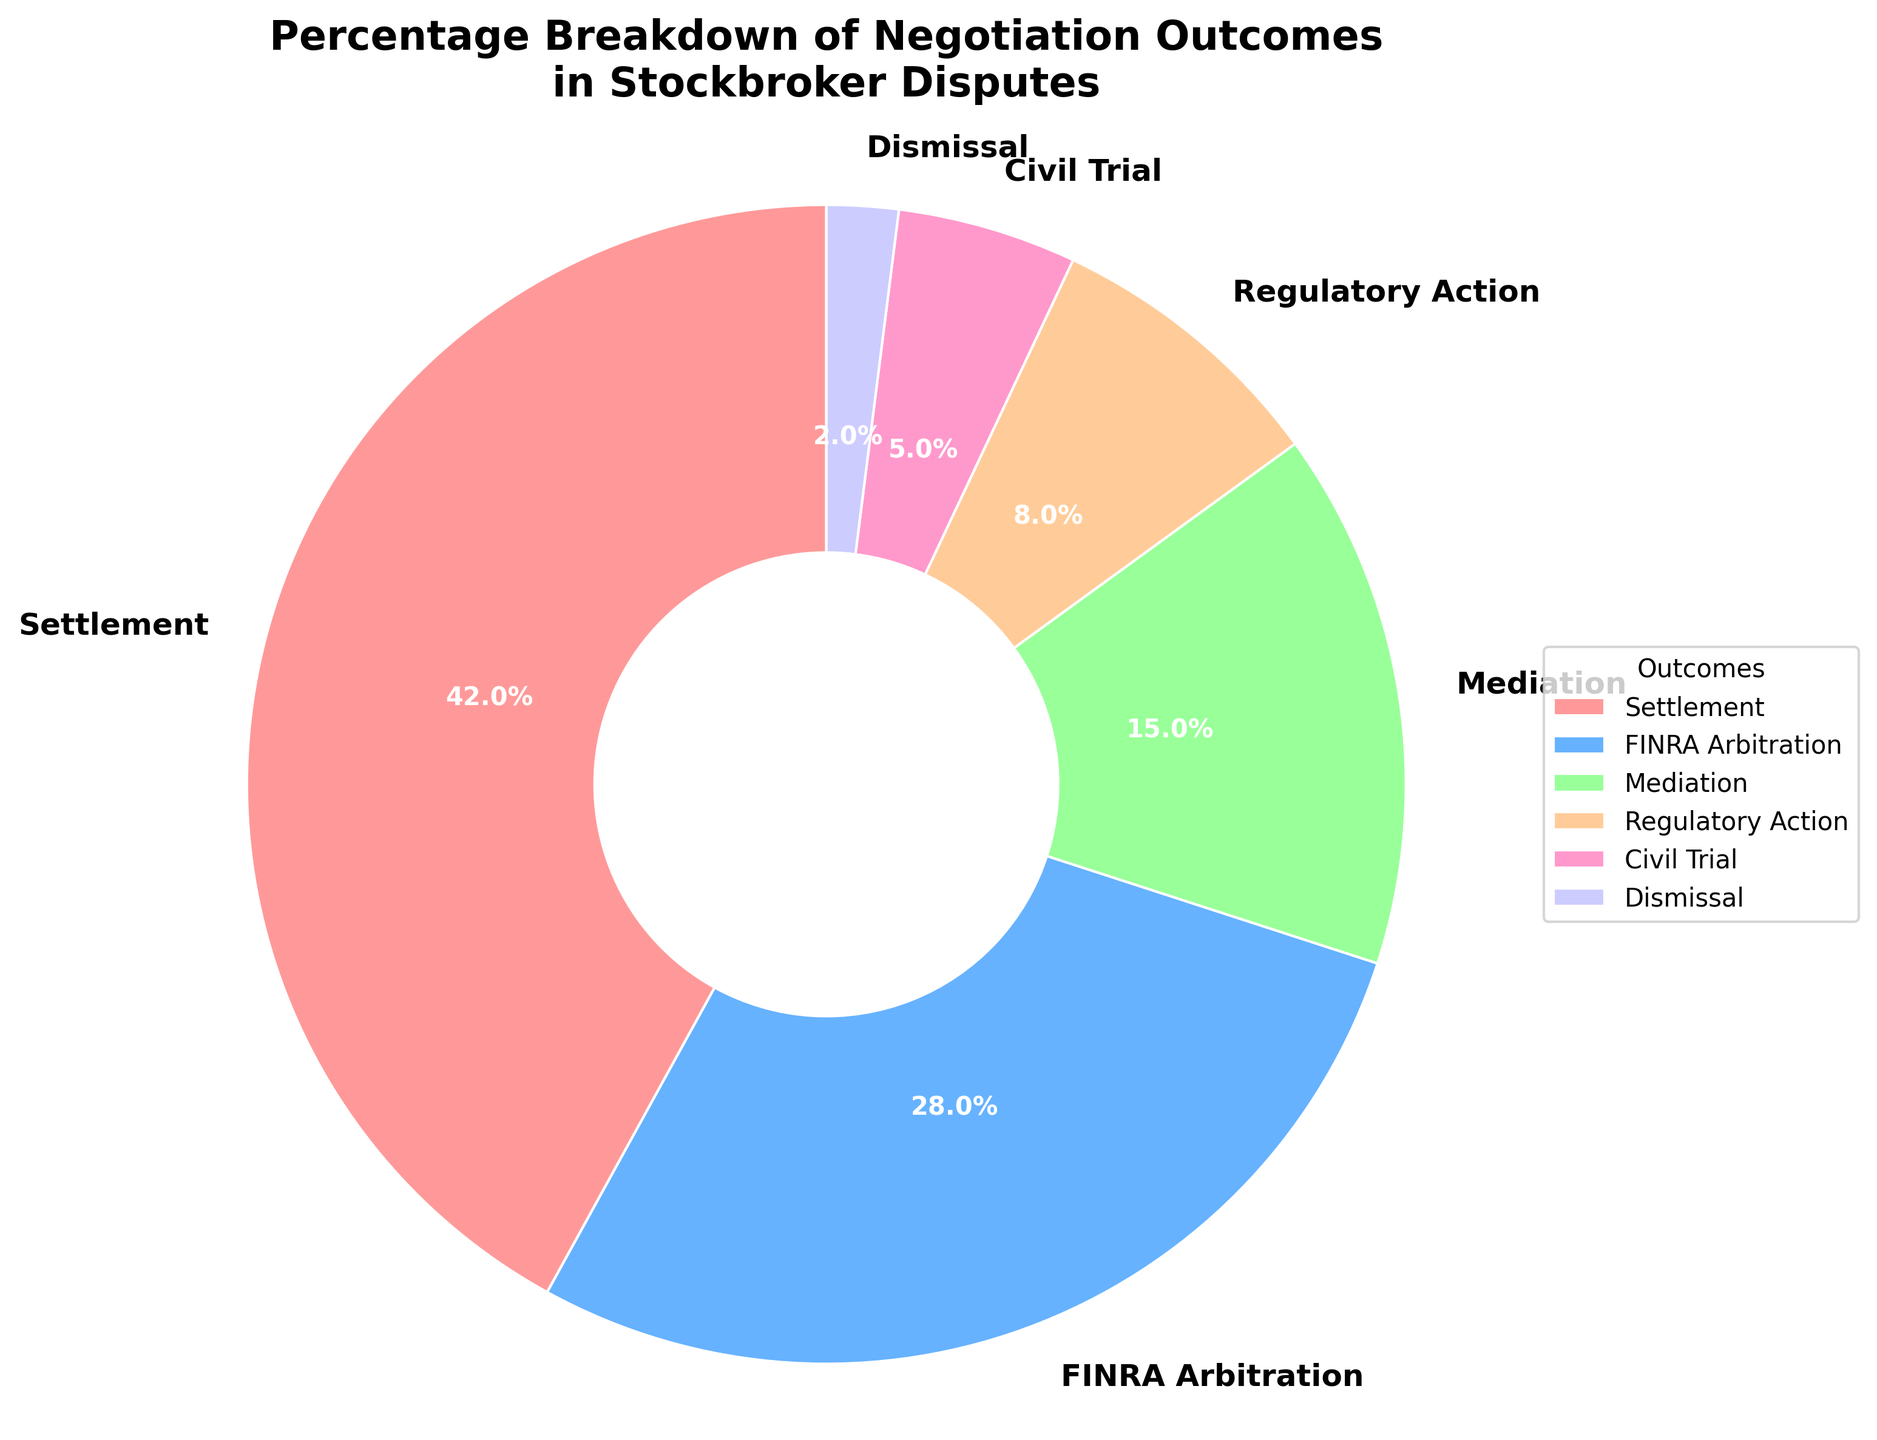What percentage of stockbroker disputes end in settlement? By looking at the figure, identify the section labeled "Settlement" and check the percentage value shown.
Answer: 42% How many times more likely is a dispute to end in settlement compared to dismissal? Compare the percentage values of "Settlement" (42%) and "Dismissal" (2%) from the figure. Compute the ratio: 42% / 2% = 21.
Answer: 21 times Which outcome has the second highest percentage in the negotiation outcomes? Identify the largest segment on the pie chart first, which is "Settlement" at 42%. Then look for the next largest segment, which is "FINRA Arbitration" at 28%.
Answer: FINRA Arbitration What is the combined percentage of disputes ending in mediation or regulatory action? Find the segments "Mediation" and "Regulatory Action" on the pie chart, add their percentages: 15% + 8% = 23%.
Answer: 23% Is the percentage of civil trials greater than or less than 10%? Look at the segment labeled "Civil Trial" on the pie chart and check its percentage, which is 5%. Since 5% is less than 10%, the answer is less.
Answer: Less What percentage of outcomes fall under either trial or dismissal? Add the percentage values of "Civil Trial" (5%) and "Dismissal" (2%) from the pie chart: 5% + 2% = 7%.
Answer: 7% What percentage of outcomes are not settlement? Subtract the percentage for "Settlement" (42%) from 100%: 100% - 42% = 58%.
Answer: 58% Which outcome is depicted using the green color? Identify the wedges by color; "Mediation" segment is using the green color (as per the provided color scheme equivalent).
Answer: Mediation 